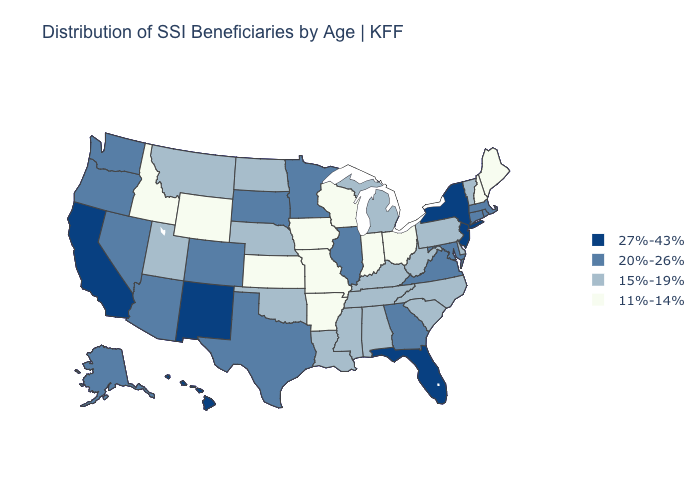Which states have the highest value in the USA?
Write a very short answer. California, Florida, Hawaii, New Jersey, New Mexico, New York. Does New Hampshire have the same value as Idaho?
Concise answer only. Yes. Does Minnesota have the same value as South Carolina?
Keep it brief. No. Does Pennsylvania have a lower value than California?
Quick response, please. Yes. Among the states that border South Dakota , which have the lowest value?
Give a very brief answer. Iowa, Wyoming. What is the highest value in the USA?
Keep it brief. 27%-43%. Name the states that have a value in the range 15%-19%?
Answer briefly. Alabama, Delaware, Kentucky, Louisiana, Michigan, Mississippi, Montana, Nebraska, North Carolina, North Dakota, Oklahoma, Pennsylvania, South Carolina, Tennessee, Utah, Vermont, West Virginia. Among the states that border Wisconsin , does Minnesota have the highest value?
Be succinct. Yes. What is the value of New Hampshire?
Keep it brief. 11%-14%. Does New Hampshire have a lower value than Wyoming?
Give a very brief answer. No. What is the highest value in the USA?
Give a very brief answer. 27%-43%. Among the states that border Washington , which have the lowest value?
Keep it brief. Idaho. What is the value of Rhode Island?
Quick response, please. 20%-26%. What is the highest value in states that border Tennessee?
Be succinct. 20%-26%. Name the states that have a value in the range 15%-19%?
Be succinct. Alabama, Delaware, Kentucky, Louisiana, Michigan, Mississippi, Montana, Nebraska, North Carolina, North Dakota, Oklahoma, Pennsylvania, South Carolina, Tennessee, Utah, Vermont, West Virginia. 